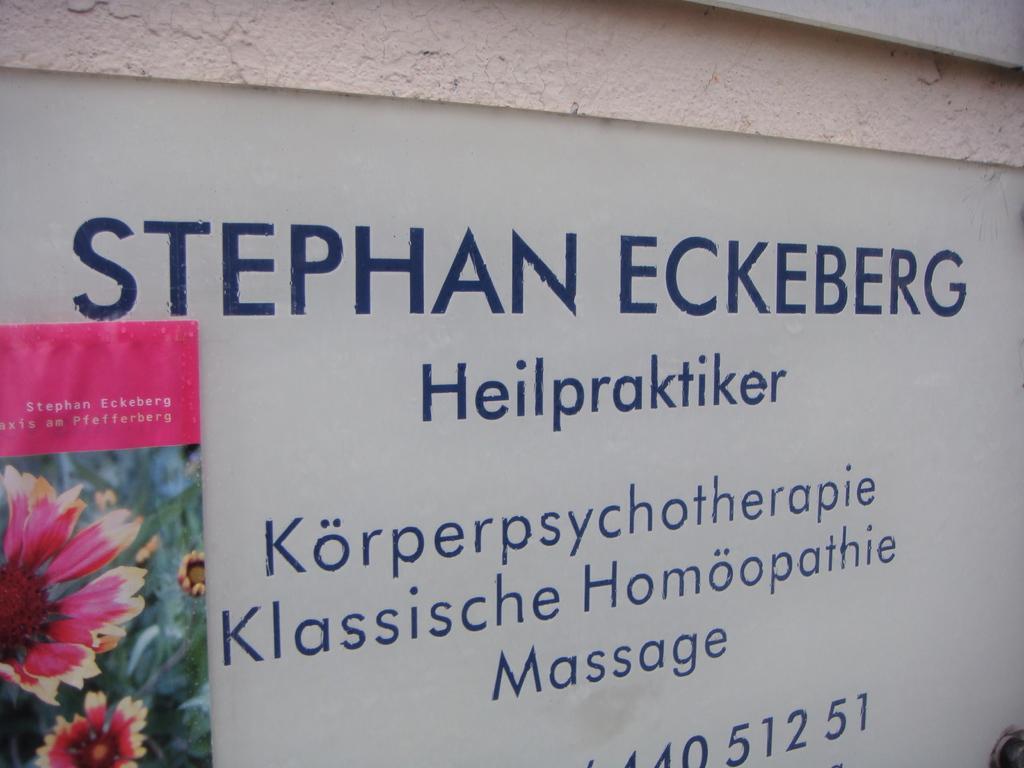How would you summarize this image in a sentence or two? In this image on the left side we can see a hoarding on the wall and there are texts written on the wall. 